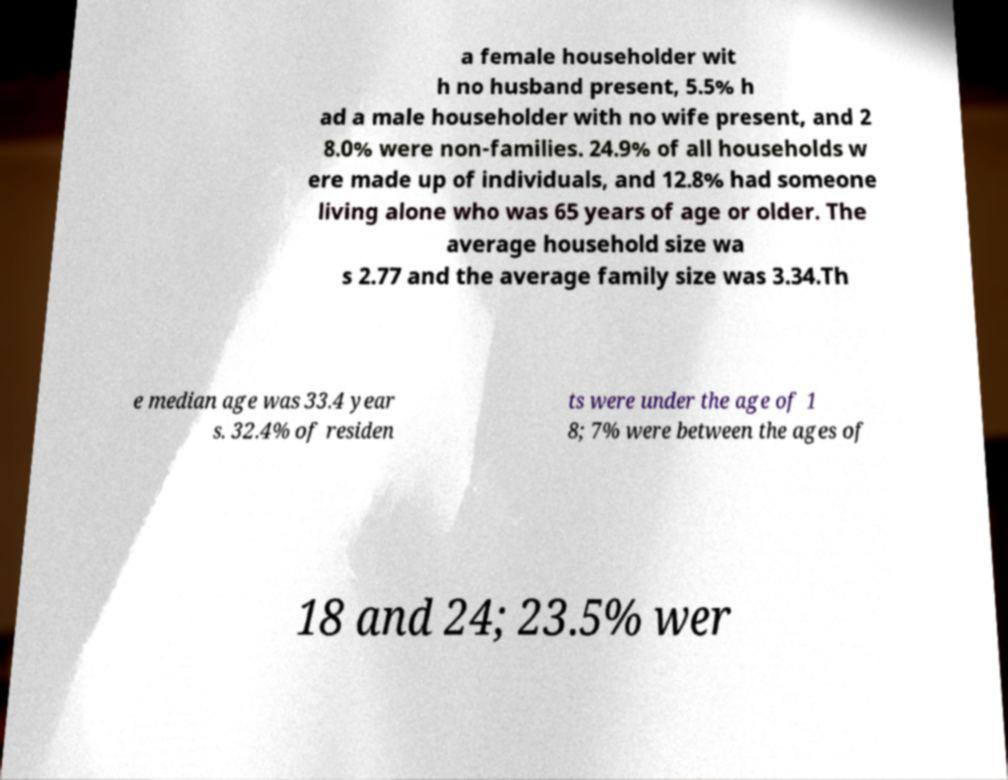Can you read and provide the text displayed in the image?This photo seems to have some interesting text. Can you extract and type it out for me? a female householder wit h no husband present, 5.5% h ad a male householder with no wife present, and 2 8.0% were non-families. 24.9% of all households w ere made up of individuals, and 12.8% had someone living alone who was 65 years of age or older. The average household size wa s 2.77 and the average family size was 3.34.Th e median age was 33.4 year s. 32.4% of residen ts were under the age of 1 8; 7% were between the ages of 18 and 24; 23.5% wer 